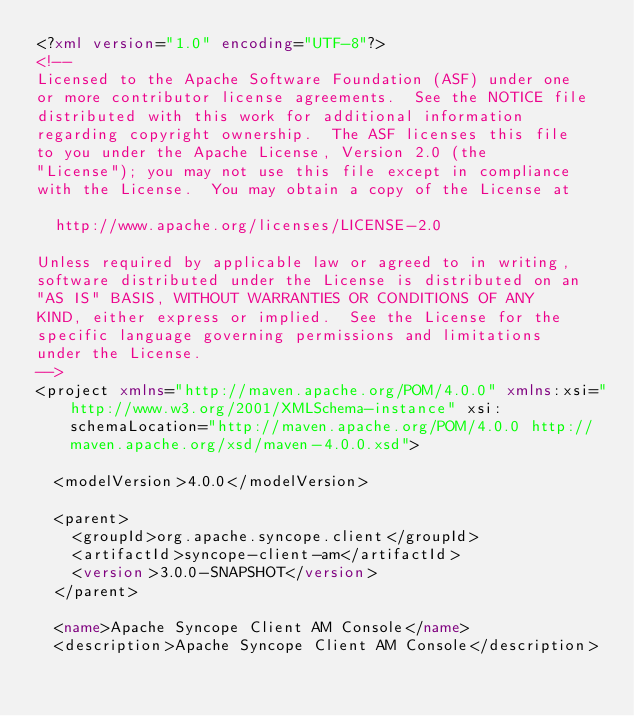<code> <loc_0><loc_0><loc_500><loc_500><_XML_><?xml version="1.0" encoding="UTF-8"?>
<!--
Licensed to the Apache Software Foundation (ASF) under one
or more contributor license agreements.  See the NOTICE file
distributed with this work for additional information
regarding copyright ownership.  The ASF licenses this file
to you under the Apache License, Version 2.0 (the
"License"); you may not use this file except in compliance
with the License.  You may obtain a copy of the License at

  http://www.apache.org/licenses/LICENSE-2.0

Unless required by applicable law or agreed to in writing,
software distributed under the License is distributed on an
"AS IS" BASIS, WITHOUT WARRANTIES OR CONDITIONS OF ANY
KIND, either express or implied.  See the License for the
specific language governing permissions and limitations
under the License.
-->
<project xmlns="http://maven.apache.org/POM/4.0.0" xmlns:xsi="http://www.w3.org/2001/XMLSchema-instance" xsi:schemaLocation="http://maven.apache.org/POM/4.0.0 http://maven.apache.org/xsd/maven-4.0.0.xsd">

  <modelVersion>4.0.0</modelVersion>

  <parent>
    <groupId>org.apache.syncope.client</groupId>
    <artifactId>syncope-client-am</artifactId>
    <version>3.0.0-SNAPSHOT</version>
  </parent>

  <name>Apache Syncope Client AM Console</name>
  <description>Apache Syncope Client AM Console</description></code> 